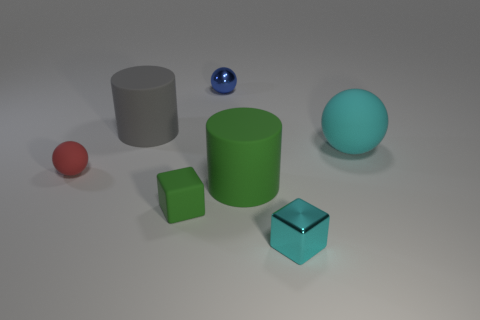Does the cyan shiny cube have the same size as the rubber sphere left of the small green rubber thing?
Provide a succinct answer. Yes. The matte sphere on the left side of the block that is left of the tiny cyan cube is what color?
Your response must be concise. Red. What number of objects are small balls that are on the left side of the small blue thing or spheres that are in front of the large cyan ball?
Your response must be concise. 1. Is the gray cylinder the same size as the blue object?
Keep it short and to the point. No. Do the tiny thing that is behind the tiny red sphere and the cyan object behind the small red rubber thing have the same shape?
Ensure brevity in your answer.  Yes. How big is the green block?
Give a very brief answer. Small. What material is the small thing that is to the left of the large rubber cylinder behind the rubber cylinder that is in front of the big cyan matte ball?
Offer a very short reply. Rubber. What number of other objects are there of the same color as the shiny cube?
Keep it short and to the point. 1. What number of green objects are either big rubber things or tiny rubber blocks?
Offer a very short reply. 2. There is a small ball behind the red rubber object; what is it made of?
Make the answer very short. Metal. 